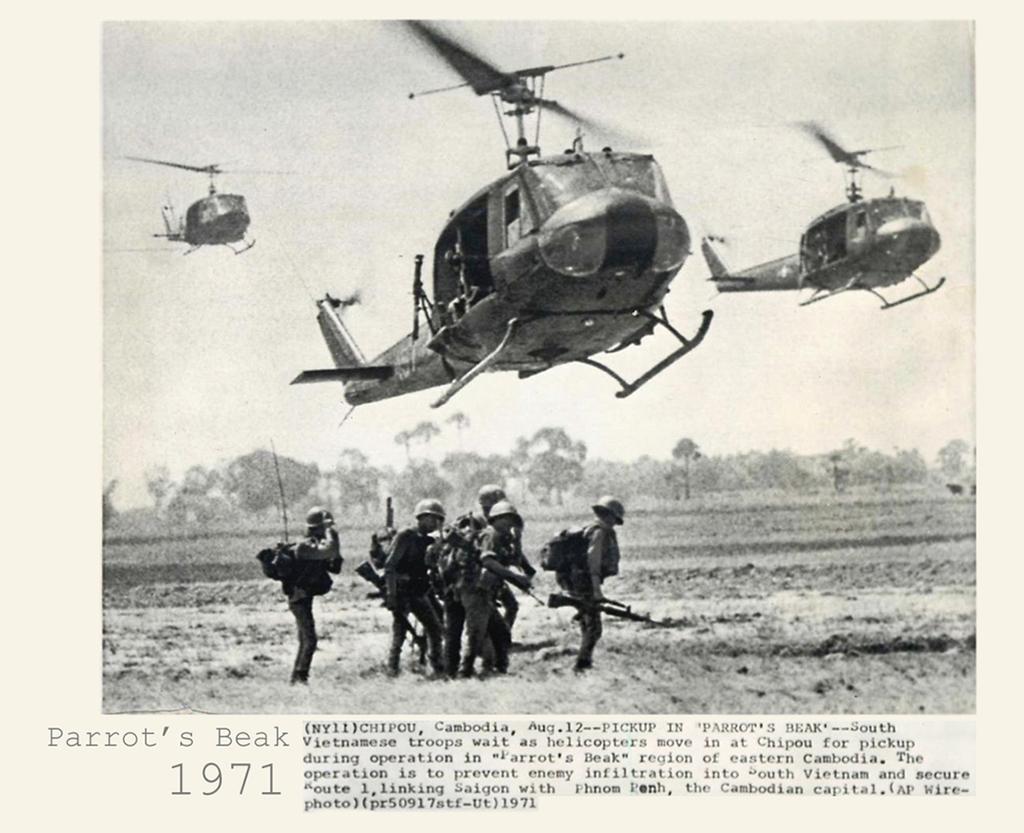Could you give a brief overview of what you see in this image? In this image we can see a poster. In the poster we can see the aircrafts and persons. The persons are carrying bags and holding guns. Behind the aircrafts we can see the sky and a group of trees. At the bottom we can see the text. 